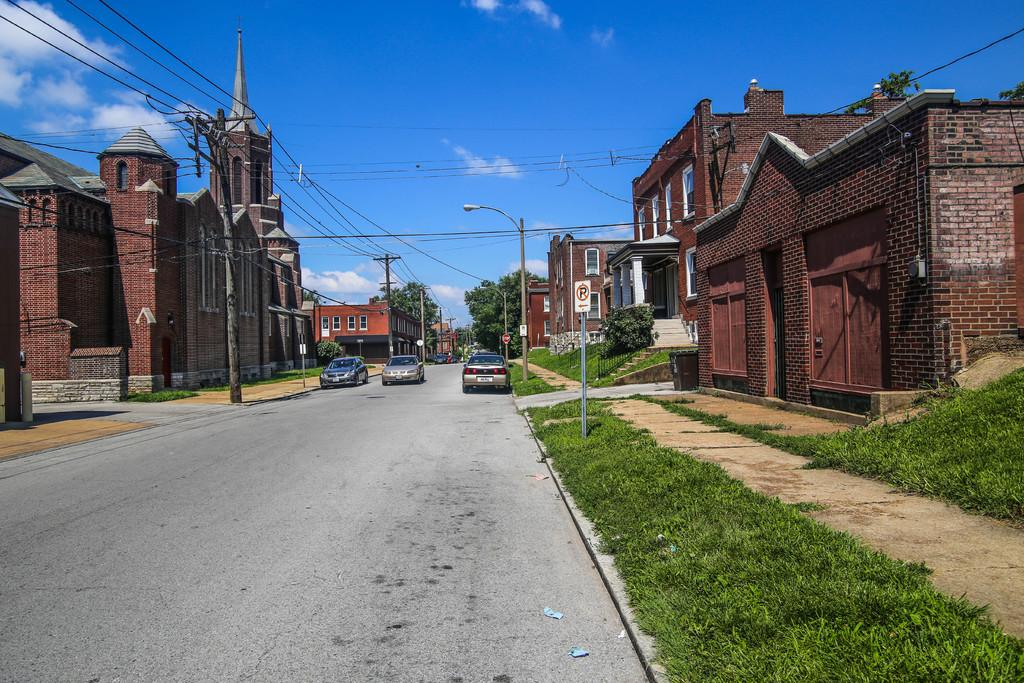<image>
Create a compact narrative representing the image presented. A picture of a street surrounded with brick buildings and a NO PARKING sign. 